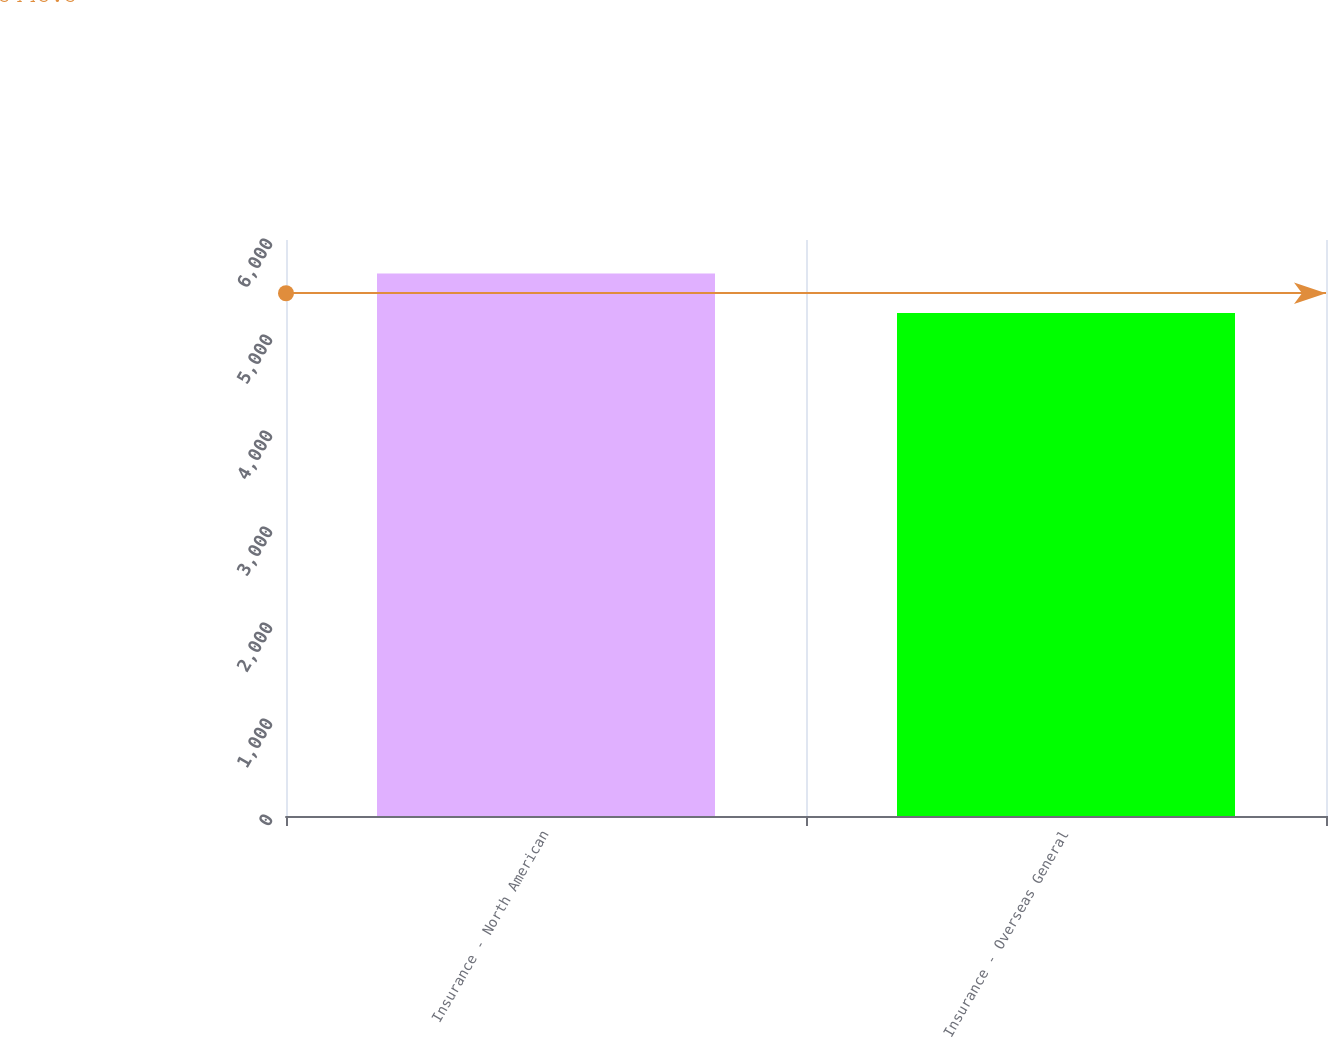Convert chart. <chart><loc_0><loc_0><loc_500><loc_500><bar_chart><fcel>Insurance - North American<fcel>Insurance - Overseas General<nl><fcel>5651<fcel>5240<nl></chart> 